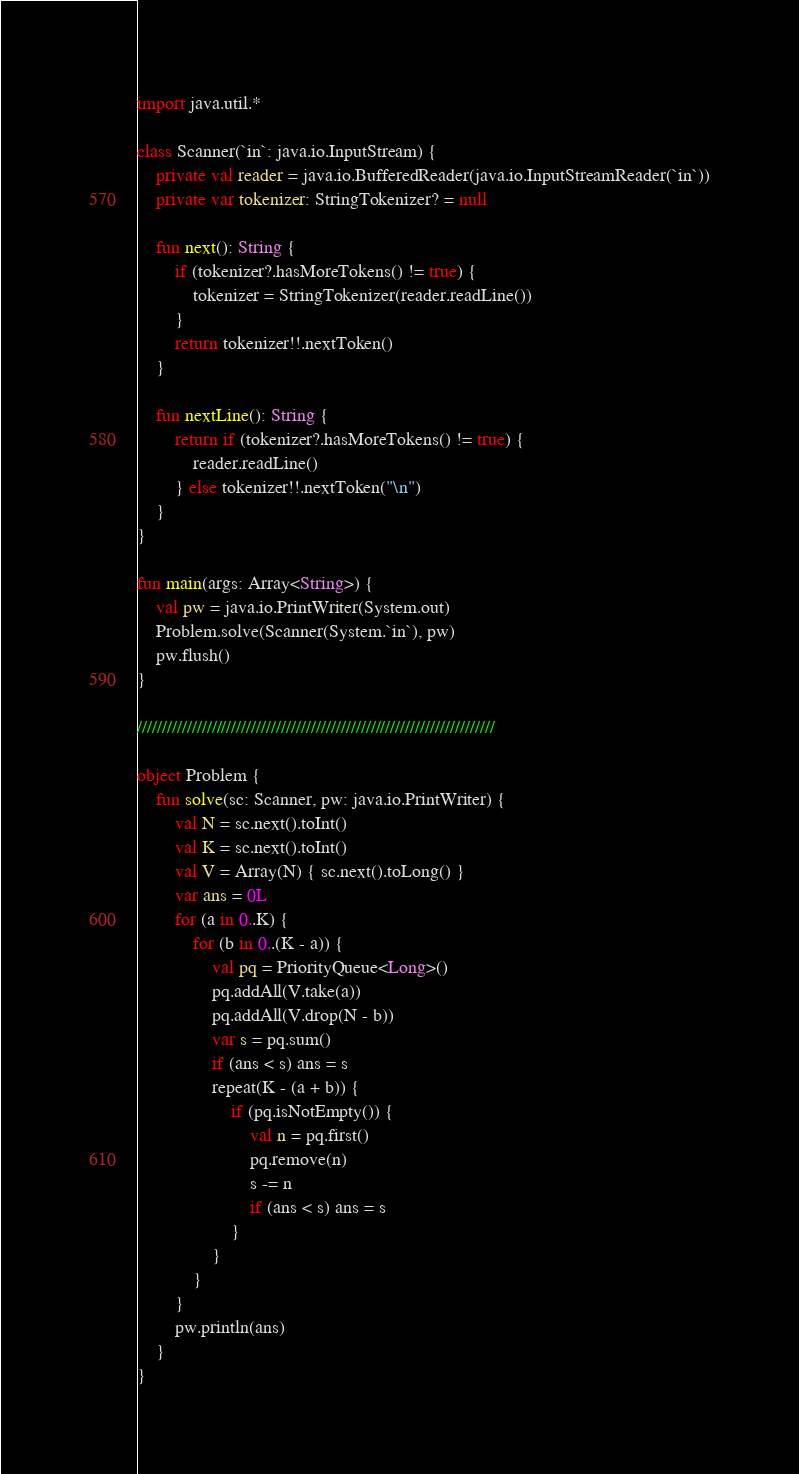Convert code to text. <code><loc_0><loc_0><loc_500><loc_500><_Kotlin_>import java.util.*

class Scanner(`in`: java.io.InputStream) {
    private val reader = java.io.BufferedReader(java.io.InputStreamReader(`in`))
    private var tokenizer: StringTokenizer? = null

    fun next(): String {
        if (tokenizer?.hasMoreTokens() != true) {
            tokenizer = StringTokenizer(reader.readLine())
        }
        return tokenizer!!.nextToken()
    }

    fun nextLine(): String {
        return if (tokenizer?.hasMoreTokens() != true) {
            reader.readLine()
        } else tokenizer!!.nextToken("\n")
    }
}

fun main(args: Array<String>) {
    val pw = java.io.PrintWriter(System.out)
    Problem.solve(Scanner(System.`in`), pw)
    pw.flush()
}

////////////////////////////////////////////////////////////////////////

object Problem {
    fun solve(sc: Scanner, pw: java.io.PrintWriter) {
        val N = sc.next().toInt()
        val K = sc.next().toInt()
        val V = Array(N) { sc.next().toLong() }
        var ans = 0L
        for (a in 0..K) {
            for (b in 0..(K - a)) {
                val pq = PriorityQueue<Long>()
                pq.addAll(V.take(a))
                pq.addAll(V.drop(N - b))
                var s = pq.sum()
                if (ans < s) ans = s
                repeat(K - (a + b)) {
                    if (pq.isNotEmpty()) {
                        val n = pq.first()
                        pq.remove(n)
                        s -= n
                        if (ans < s) ans = s
                    }
                }
            }
        }
        pw.println(ans)
    }
}
</code> 